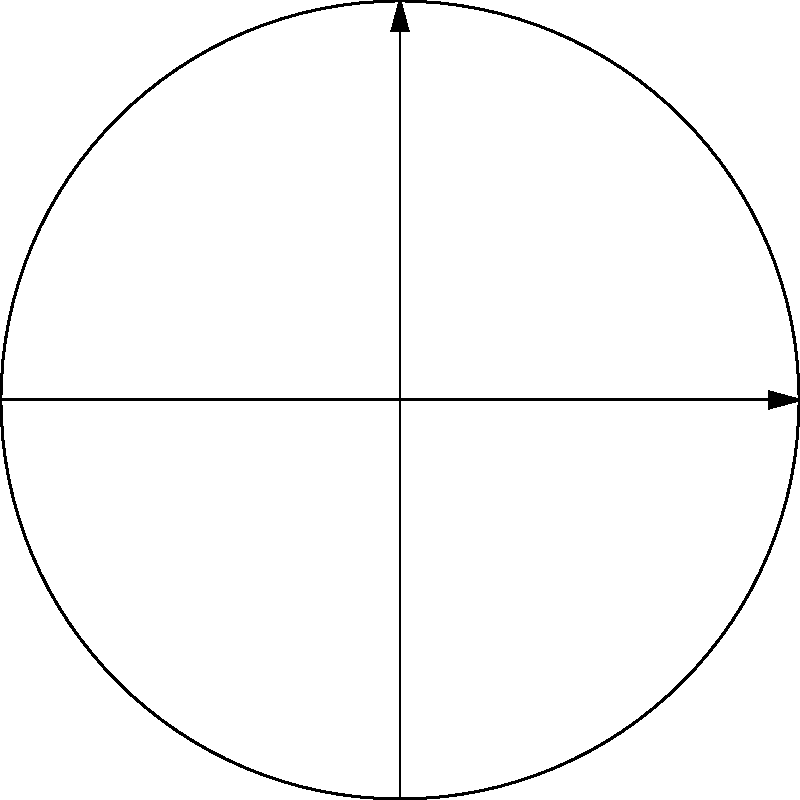In this polar coordinate representation of geopolitical influence zones, three major powers (A, B, and C) are shown. Given that power A's influence extends from 0° to 120° and from 240° to 360°, while power B's influence spans from 120° to 240°, what is the total angular measure of power A's influence zone? To solve this problem, we need to follow these steps:

1. Identify the influence zones of power A:
   - Zone 1: 0° to 120°
   - Zone 2: 240° to 360°

2. Calculate the angular measure of each zone:
   - Zone 1: 120° - 0° = 120°
   - Zone 2: 360° - 240° = 120°

3. Sum up the angular measures:
   Total angular measure = Zone 1 + Zone 2
   $$ 120° + 120° = 240° $$

4. Verify the result:
   - The entire circle is 360°
   - Power B's influence zone is 120°
   - The remaining 240° belongs to power A

Therefore, the total angular measure of power A's influence zone is 240°.
Answer: 240° 